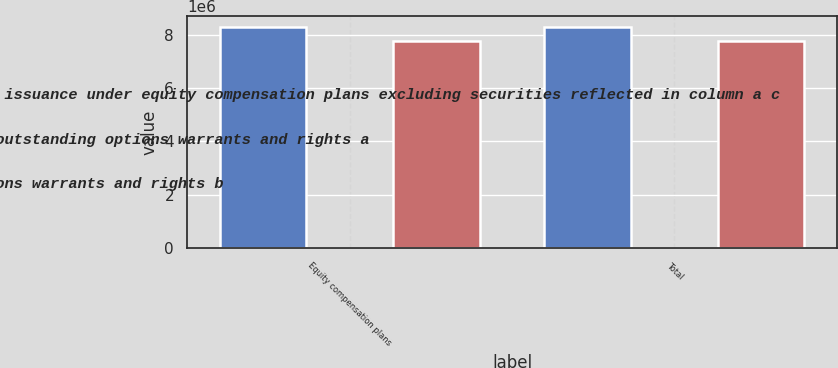Convert chart to OTSL. <chart><loc_0><loc_0><loc_500><loc_500><stacked_bar_chart><ecel><fcel>Equity compensation plans<fcel>Total<nl><fcel>Number of securities remaining available for future issuance under equity compensation plans excluding securities reflected in column a c<fcel>8.28995e+06<fcel>8.28995e+06<nl><fcel>Number of securities to be issued upon exercise of outstanding options warrants and rights a<fcel>60.28<fcel>60.28<nl><fcel>Weighted average exercise price of outstanding options warrants and rights b<fcel>7.77248e+06<fcel>7.77248e+06<nl></chart> 